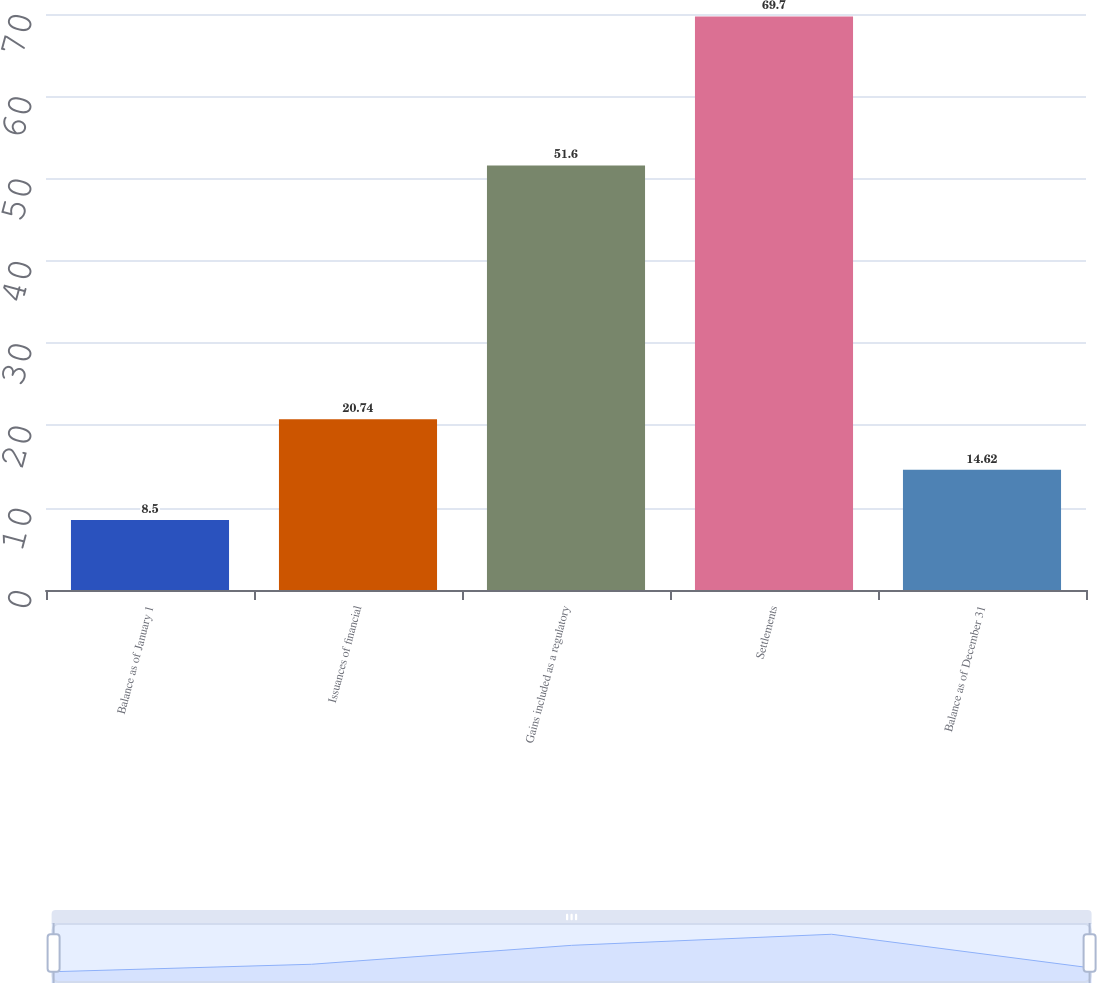<chart> <loc_0><loc_0><loc_500><loc_500><bar_chart><fcel>Balance as of January 1<fcel>Issuances of financial<fcel>Gains included as a regulatory<fcel>Settlements<fcel>Balance as of December 31<nl><fcel>8.5<fcel>20.74<fcel>51.6<fcel>69.7<fcel>14.62<nl></chart> 